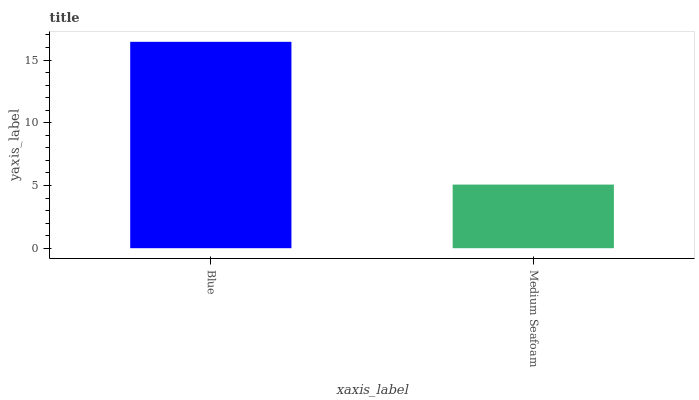Is Medium Seafoam the maximum?
Answer yes or no. No. Is Blue greater than Medium Seafoam?
Answer yes or no. Yes. Is Medium Seafoam less than Blue?
Answer yes or no. Yes. Is Medium Seafoam greater than Blue?
Answer yes or no. No. Is Blue less than Medium Seafoam?
Answer yes or no. No. Is Blue the high median?
Answer yes or no. Yes. Is Medium Seafoam the low median?
Answer yes or no. Yes. Is Medium Seafoam the high median?
Answer yes or no. No. Is Blue the low median?
Answer yes or no. No. 